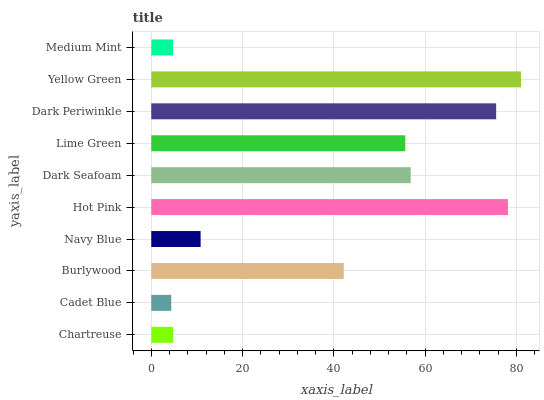Is Cadet Blue the minimum?
Answer yes or no. Yes. Is Yellow Green the maximum?
Answer yes or no. Yes. Is Burlywood the minimum?
Answer yes or no. No. Is Burlywood the maximum?
Answer yes or no. No. Is Burlywood greater than Cadet Blue?
Answer yes or no. Yes. Is Cadet Blue less than Burlywood?
Answer yes or no. Yes. Is Cadet Blue greater than Burlywood?
Answer yes or no. No. Is Burlywood less than Cadet Blue?
Answer yes or no. No. Is Lime Green the high median?
Answer yes or no. Yes. Is Burlywood the low median?
Answer yes or no. Yes. Is Medium Mint the high median?
Answer yes or no. No. Is Cadet Blue the low median?
Answer yes or no. No. 